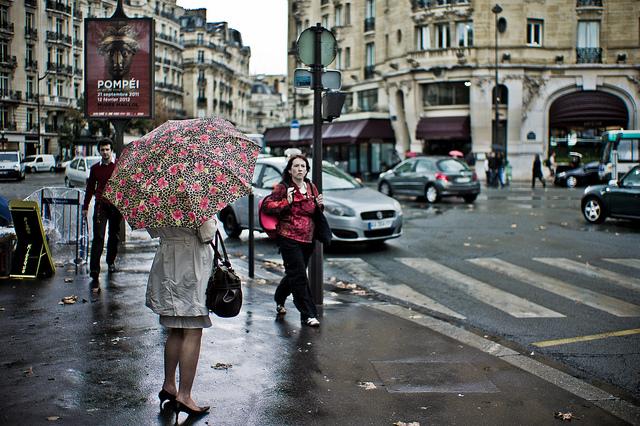Is the woman in the red shirt getting wet?
Be succinct. Yes. Is it raining?
Quick response, please. Yes. What type of footwear is the woman with the umbrella wearing?
Write a very short answer. High heels. What color is the majority of the umbrellas?
Give a very brief answer. Pink. 